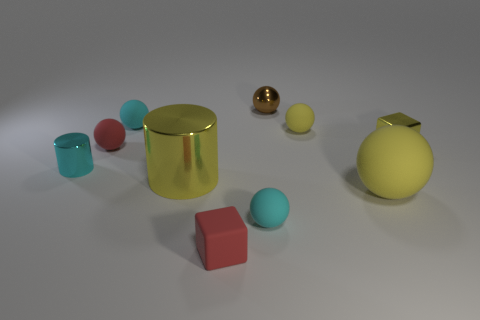There is a tiny red object that is the same shape as the tiny yellow shiny object; what is it made of?
Your response must be concise. Rubber. What number of red rubber objects are the same shape as the brown metal thing?
Your response must be concise. 1. What is the material of the tiny yellow sphere?
Offer a terse response. Rubber. Do the small cylinder and the small ball that is in front of the yellow metallic cube have the same color?
Offer a very short reply. Yes. How many cubes are tiny matte things or yellow metal things?
Offer a very short reply. 2. The small ball in front of the tiny cyan cylinder is what color?
Provide a succinct answer. Cyan. There is a rubber thing that is the same color as the big matte ball; what is its shape?
Ensure brevity in your answer.  Sphere. How many yellow metal things are the same size as the brown object?
Give a very brief answer. 1. Does the red object behind the metallic cube have the same shape as the tiny cyan rubber thing that is right of the red block?
Keep it short and to the point. Yes. There is a cyan sphere that is on the right side of the tiny block that is in front of the yellow shiny thing that is right of the tiny yellow rubber sphere; what is it made of?
Give a very brief answer. Rubber. 